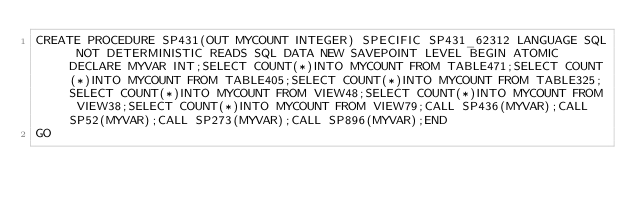<code> <loc_0><loc_0><loc_500><loc_500><_SQL_>CREATE PROCEDURE SP431(OUT MYCOUNT INTEGER) SPECIFIC SP431_62312 LANGUAGE SQL NOT DETERMINISTIC READS SQL DATA NEW SAVEPOINT LEVEL BEGIN ATOMIC DECLARE MYVAR INT;SELECT COUNT(*)INTO MYCOUNT FROM TABLE471;SELECT COUNT(*)INTO MYCOUNT FROM TABLE405;SELECT COUNT(*)INTO MYCOUNT FROM TABLE325;SELECT COUNT(*)INTO MYCOUNT FROM VIEW48;SELECT COUNT(*)INTO MYCOUNT FROM VIEW38;SELECT COUNT(*)INTO MYCOUNT FROM VIEW79;CALL SP436(MYVAR);CALL SP52(MYVAR);CALL SP273(MYVAR);CALL SP896(MYVAR);END
GO</code> 